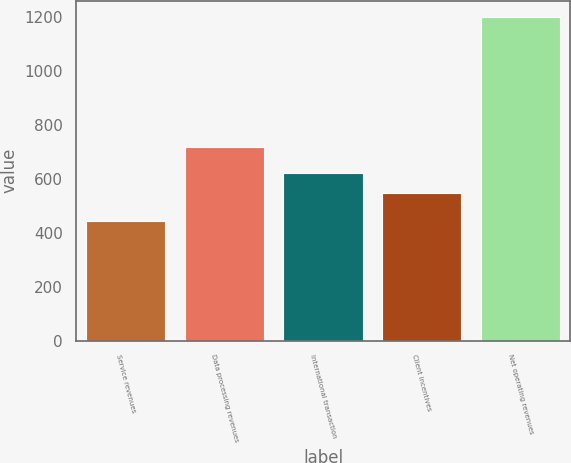<chart> <loc_0><loc_0><loc_500><loc_500><bar_chart><fcel>Service revenues<fcel>Data processing revenues<fcel>International transaction<fcel>Client incentives<fcel>Net operating revenues<nl><fcel>445<fcel>720<fcel>623.7<fcel>548<fcel>1202<nl></chart> 